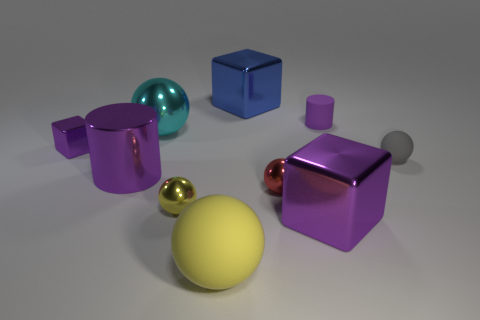There is a tiny object that is to the left of the large cyan metal thing; what is its shape?
Make the answer very short. Cube. The yellow thing behind the large shiny block right of the blue metal thing is made of what material?
Your answer should be very brief. Metal. Is the number of large yellow things that are to the right of the small purple rubber thing greater than the number of purple metallic cubes?
Ensure brevity in your answer.  No. What number of other objects are there of the same color as the small metal cube?
Offer a very short reply. 3. What is the shape of the yellow object that is the same size as the gray rubber thing?
Give a very brief answer. Sphere. What number of purple metal objects are on the right side of the purple cylinder to the right of the large cube that is in front of the small purple shiny thing?
Provide a short and direct response. 0. What number of matte things are either big yellow spheres or tiny red cylinders?
Make the answer very short. 1. There is a big shiny thing that is behind the gray thing and in front of the large blue cube; what is its color?
Make the answer very short. Cyan. There is a purple cylinder left of the matte cylinder; is its size the same as the large blue thing?
Ensure brevity in your answer.  Yes. How many objects are either small objects that are right of the small red metal sphere or red spheres?
Provide a short and direct response. 3. 